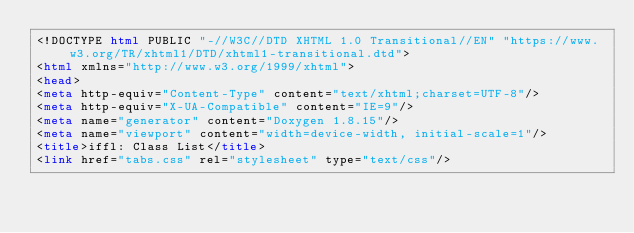<code> <loc_0><loc_0><loc_500><loc_500><_HTML_><!DOCTYPE html PUBLIC "-//W3C//DTD XHTML 1.0 Transitional//EN" "https://www.w3.org/TR/xhtml1/DTD/xhtml1-transitional.dtd">
<html xmlns="http://www.w3.org/1999/xhtml">
<head>
<meta http-equiv="Content-Type" content="text/xhtml;charset=UTF-8"/>
<meta http-equiv="X-UA-Compatible" content="IE=9"/>
<meta name="generator" content="Doxygen 1.8.15"/>
<meta name="viewport" content="width=device-width, initial-scale=1"/>
<title>iffl: Class List</title>
<link href="tabs.css" rel="stylesheet" type="text/css"/></code> 